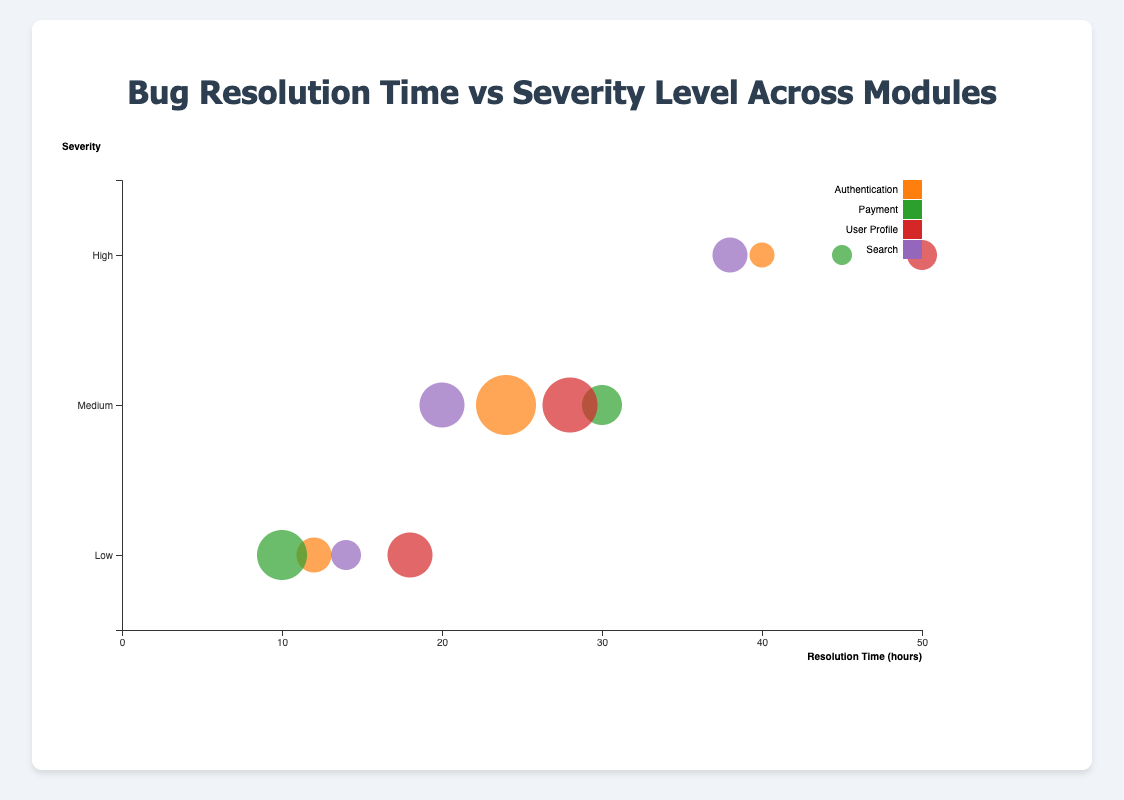What is the title of the chart? The title is located at the top of the chart and it reads, "Bug Resolution Time vs Severity Level Across Modules". Therefore, the title of the chart is easy to identify.
Answer: Bug Resolution Time vs Severity Level Across Modules Which severity level has the highest resolution time in the User Profile module? By looking at the Y-axis for "User Profile" and finding the highest bubble on the X-axis, the highest severity level resolution time corresponds to "High". The resolution time is 50 hours.
Answer: High How many bubbles represent the Payment module? The color legend indicates that the Payment module bubbles are green. By counting the green bubbles, the total number is 3.
Answer: 3 Compare the resolution time for High severity bugs in the Authentication and Payment modules. Which one has a higher resolution time? Look at the bubbles for "High" severity in both Authentication and Payment modules. Authentication has a resolution time of 40 hours and Payment has a resolution time of 45 hours. The Payment module has a higher resolution time.
Answer: Payment What is the total bug count for Medium severity in the Payment module? Identify the bubble for "Medium" severity in the Payment module, which shows a count of 6 bugs. Since there's only one such bubble, the total bug count is 6.
Answer: 6 Calculate the average resolution time for Low severity bugs across all modules. First, extract resolution times for Low severity (Authentication: 12, Payment: 10, User Profile: 18, Search: 14). Sum these times (12 + 10 + 18 + 14 = 54) and divide by the number of data points (4). The average is 54 / 4 = 13.5 hours.
Answer: 13.5 Which module has the smallest bubble for High severity bugs? The bubble size represents the bug count. By comparing the High severity bubbles, the Payment module has the smallest bubble with a count of 2 bugs.
Answer: Payment For Medium severity bugs, which module has the shortest resolution time and what is it? Find the module with the shortest bubble on the X-axis for Medium severity. The Search module has the shortest resolution time of 20 hours for Medium severity.
Answer: Search What is the difference in resolution time for Medium severity bugs between the Authentication and User Profile modules? Identify the resolution times for Medium severity in Authentication (24 hours) and User Profile (28 hours). The difference is 28 - 24 = 4 hours.
Answer: 4 